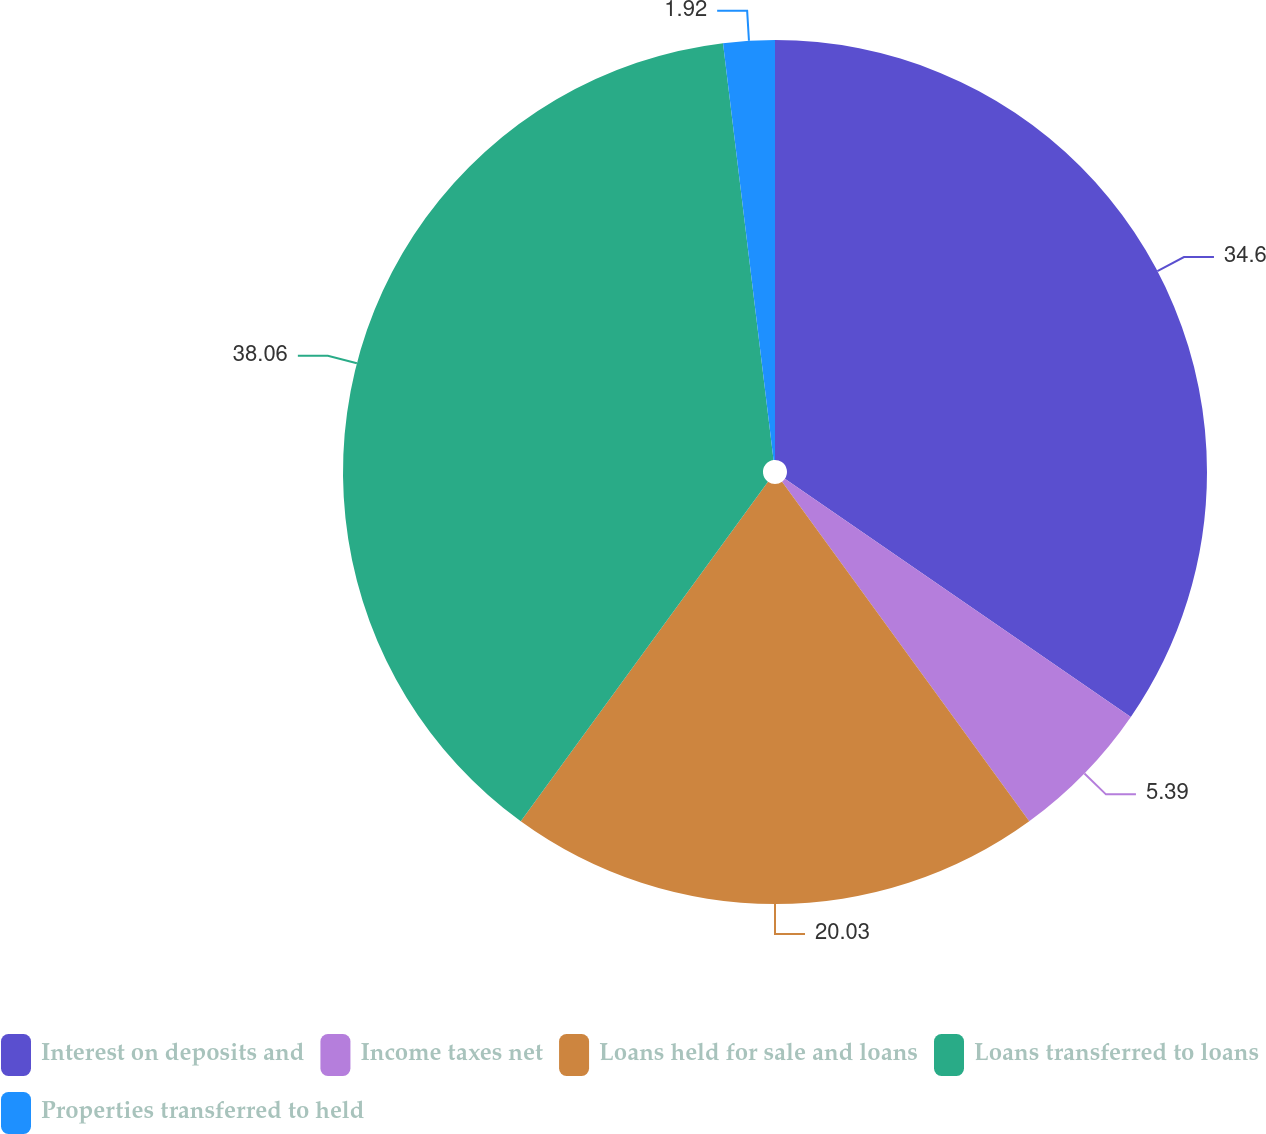<chart> <loc_0><loc_0><loc_500><loc_500><pie_chart><fcel>Interest on deposits and<fcel>Income taxes net<fcel>Loans held for sale and loans<fcel>Loans transferred to loans<fcel>Properties transferred to held<nl><fcel>34.6%<fcel>5.39%<fcel>20.03%<fcel>38.07%<fcel>1.92%<nl></chart> 